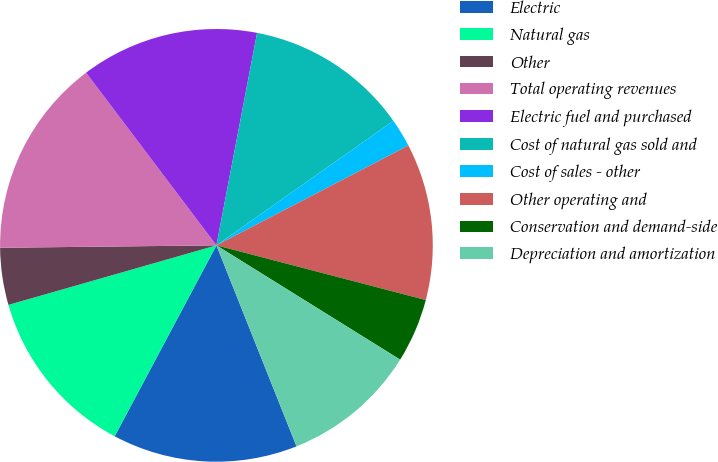Convert chart to OTSL. <chart><loc_0><loc_0><loc_500><loc_500><pie_chart><fcel>Electric<fcel>Natural gas<fcel>Other<fcel>Total operating revenues<fcel>Electric fuel and purchased<fcel>Cost of natural gas sold and<fcel>Cost of sales - other<fcel>Other operating and<fcel>Conservation and demand-side<fcel>Depreciation and amortization<nl><fcel>13.83%<fcel>12.77%<fcel>4.26%<fcel>14.89%<fcel>13.3%<fcel>12.23%<fcel>2.13%<fcel>11.7%<fcel>4.79%<fcel>10.11%<nl></chart> 